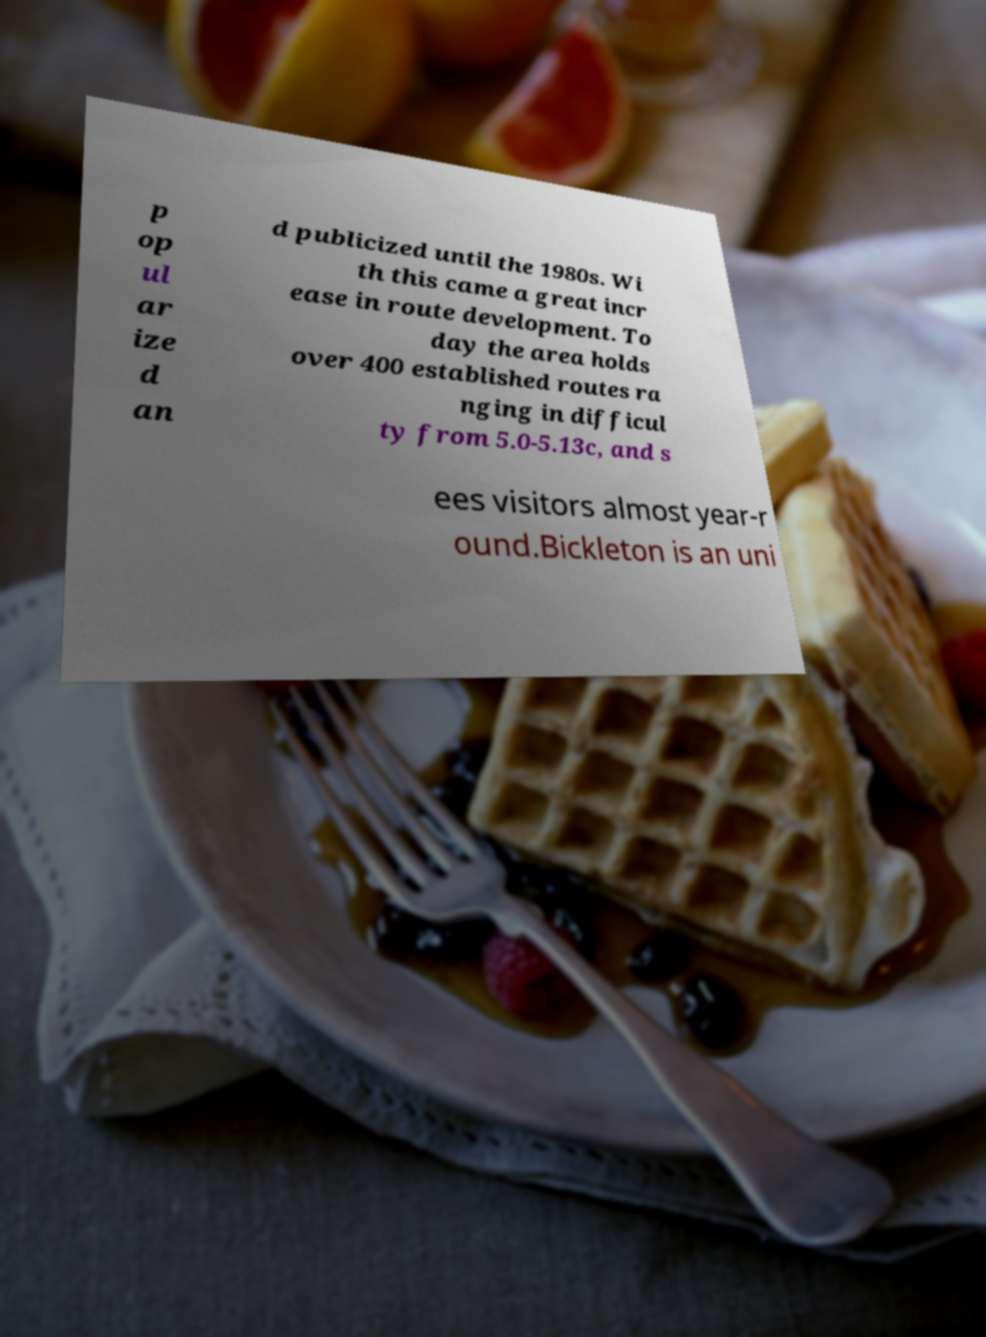Can you accurately transcribe the text from the provided image for me? p op ul ar ize d an d publicized until the 1980s. Wi th this came a great incr ease in route development. To day the area holds over 400 established routes ra nging in difficul ty from 5.0-5.13c, and s ees visitors almost year-r ound.Bickleton is an uni 